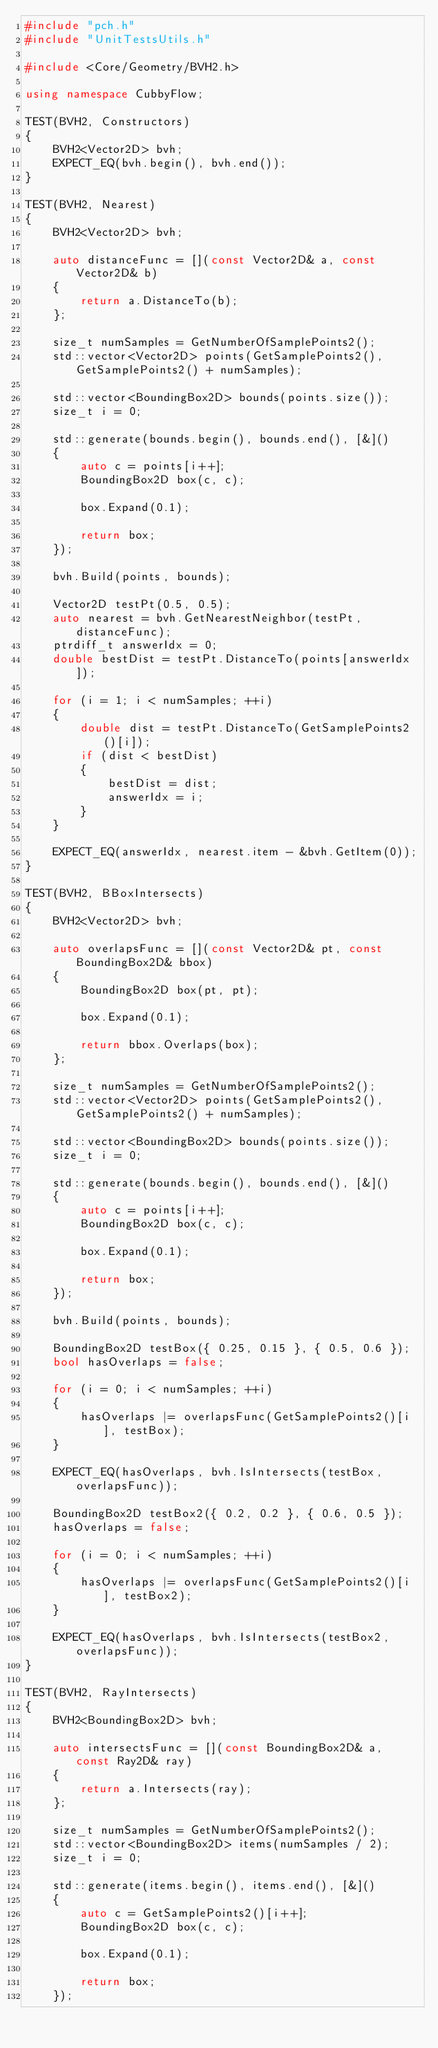<code> <loc_0><loc_0><loc_500><loc_500><_C++_>#include "pch.h"
#include "UnitTestsUtils.h"

#include <Core/Geometry/BVH2.h>

using namespace CubbyFlow;

TEST(BVH2, Constructors)
{
	BVH2<Vector2D> bvh;
	EXPECT_EQ(bvh.begin(), bvh.end());
}

TEST(BVH2, Nearest)
{
	BVH2<Vector2D> bvh;

	auto distanceFunc = [](const Vector2D& a, const Vector2D& b)
	{
		return a.DistanceTo(b);
	};

	size_t numSamples = GetNumberOfSamplePoints2();
	std::vector<Vector2D> points(GetSamplePoints2(), GetSamplePoints2() + numSamples);

	std::vector<BoundingBox2D> bounds(points.size());
	size_t i = 0;

	std::generate(bounds.begin(), bounds.end(), [&]()
	{
		auto c = points[i++];
		BoundingBox2D box(c, c);

		box.Expand(0.1);

		return box;
	});

	bvh.Build(points, bounds);

	Vector2D testPt(0.5, 0.5);
	auto nearest = bvh.GetNearestNeighbor(testPt, distanceFunc);
	ptrdiff_t answerIdx = 0;
	double bestDist = testPt.DistanceTo(points[answerIdx]);

	for (i = 1; i < numSamples; ++i)
	{
		double dist = testPt.DistanceTo(GetSamplePoints2()[i]);
		if (dist < bestDist)
		{
			bestDist = dist;
			answerIdx = i;
		}
	}

	EXPECT_EQ(answerIdx, nearest.item - &bvh.GetItem(0));
}

TEST(BVH2, BBoxIntersects)
{
	BVH2<Vector2D> bvh;

	auto overlapsFunc = [](const Vector2D& pt, const BoundingBox2D& bbox)
	{
		BoundingBox2D box(pt, pt);

		box.Expand(0.1);

		return bbox.Overlaps(box);
	};

	size_t numSamples = GetNumberOfSamplePoints2();
	std::vector<Vector2D> points(GetSamplePoints2(), GetSamplePoints2() + numSamples);

	std::vector<BoundingBox2D> bounds(points.size());
	size_t i = 0;

	std::generate(bounds.begin(), bounds.end(), [&]()
	{
		auto c = points[i++];
		BoundingBox2D box(c, c);

		box.Expand(0.1);

		return box;
	});

	bvh.Build(points, bounds);

	BoundingBox2D testBox({ 0.25, 0.15 }, { 0.5, 0.6 });
	bool hasOverlaps = false;

	for (i = 0; i < numSamples; ++i)
	{
		hasOverlaps |= overlapsFunc(GetSamplePoints2()[i], testBox);
	}

	EXPECT_EQ(hasOverlaps, bvh.IsIntersects(testBox, overlapsFunc));

	BoundingBox2D testBox2({ 0.2, 0.2 }, { 0.6, 0.5 });
	hasOverlaps = false;

	for (i = 0; i < numSamples; ++i)
	{
		hasOverlaps |= overlapsFunc(GetSamplePoints2()[i], testBox2);
	}

	EXPECT_EQ(hasOverlaps, bvh.IsIntersects(testBox2, overlapsFunc));
}

TEST(BVH2, RayIntersects)
{
	BVH2<BoundingBox2D> bvh;

	auto intersectsFunc = [](const BoundingBox2D& a, const Ray2D& ray)
	{
		return a.Intersects(ray);
	};

	size_t numSamples = GetNumberOfSamplePoints2();
	std::vector<BoundingBox2D> items(numSamples / 2);
	size_t i = 0;

	std::generate(items.begin(), items.end(), [&]()
	{
		auto c = GetSamplePoints2()[i++];
		BoundingBox2D box(c, c);

		box.Expand(0.1);

		return box;
	});
</code> 